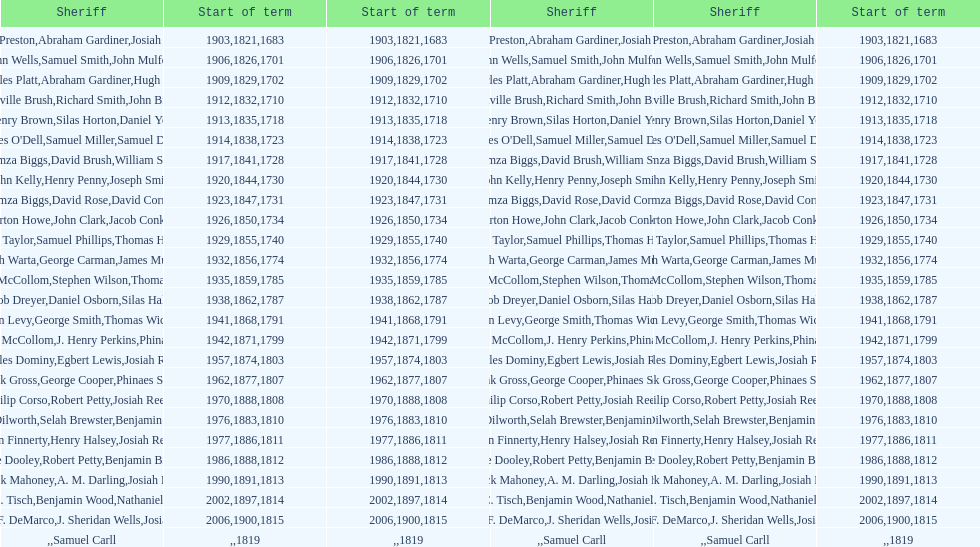How many sheriff's have the last name biggs? 1. 